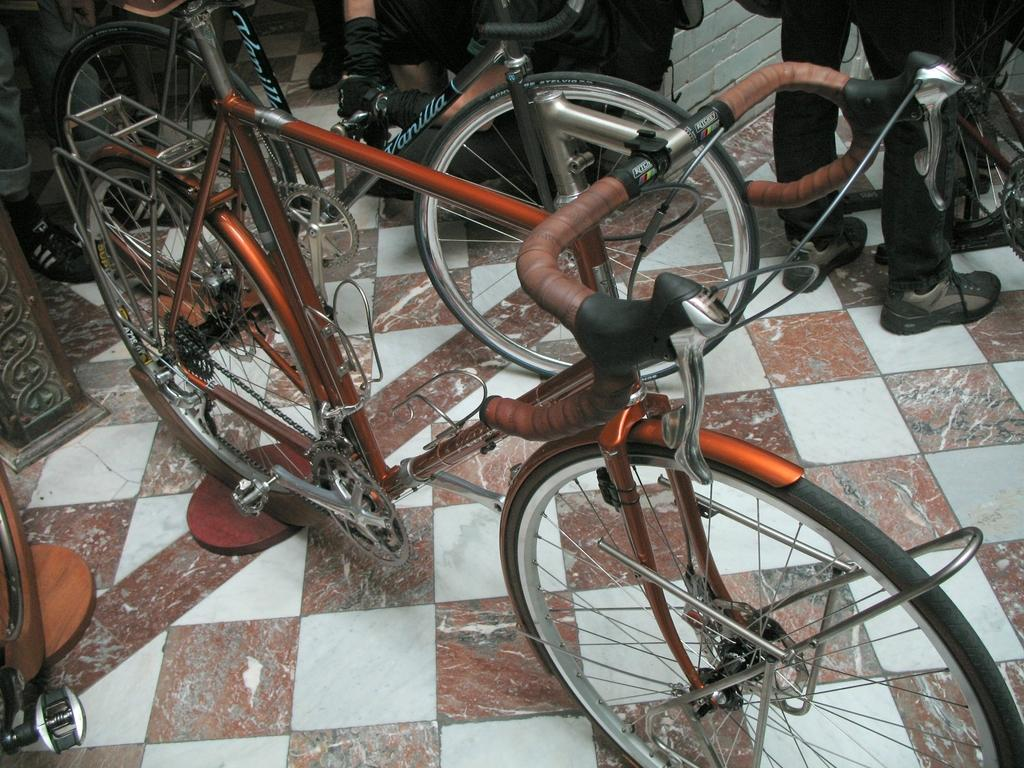What type of vehicle is in the image? There is an orange color racing cycle in the image. What is the flooring like where the racing cycle is placed? The racing cycle is placed on white and brown flooring tiles. Are there any people present in the image? Yes, there are people standing near the racing cycle. What type of suit is the wren wearing while standing near the racing cycle? There is no wren or suit present in the image; it features a racing cycle and people. 